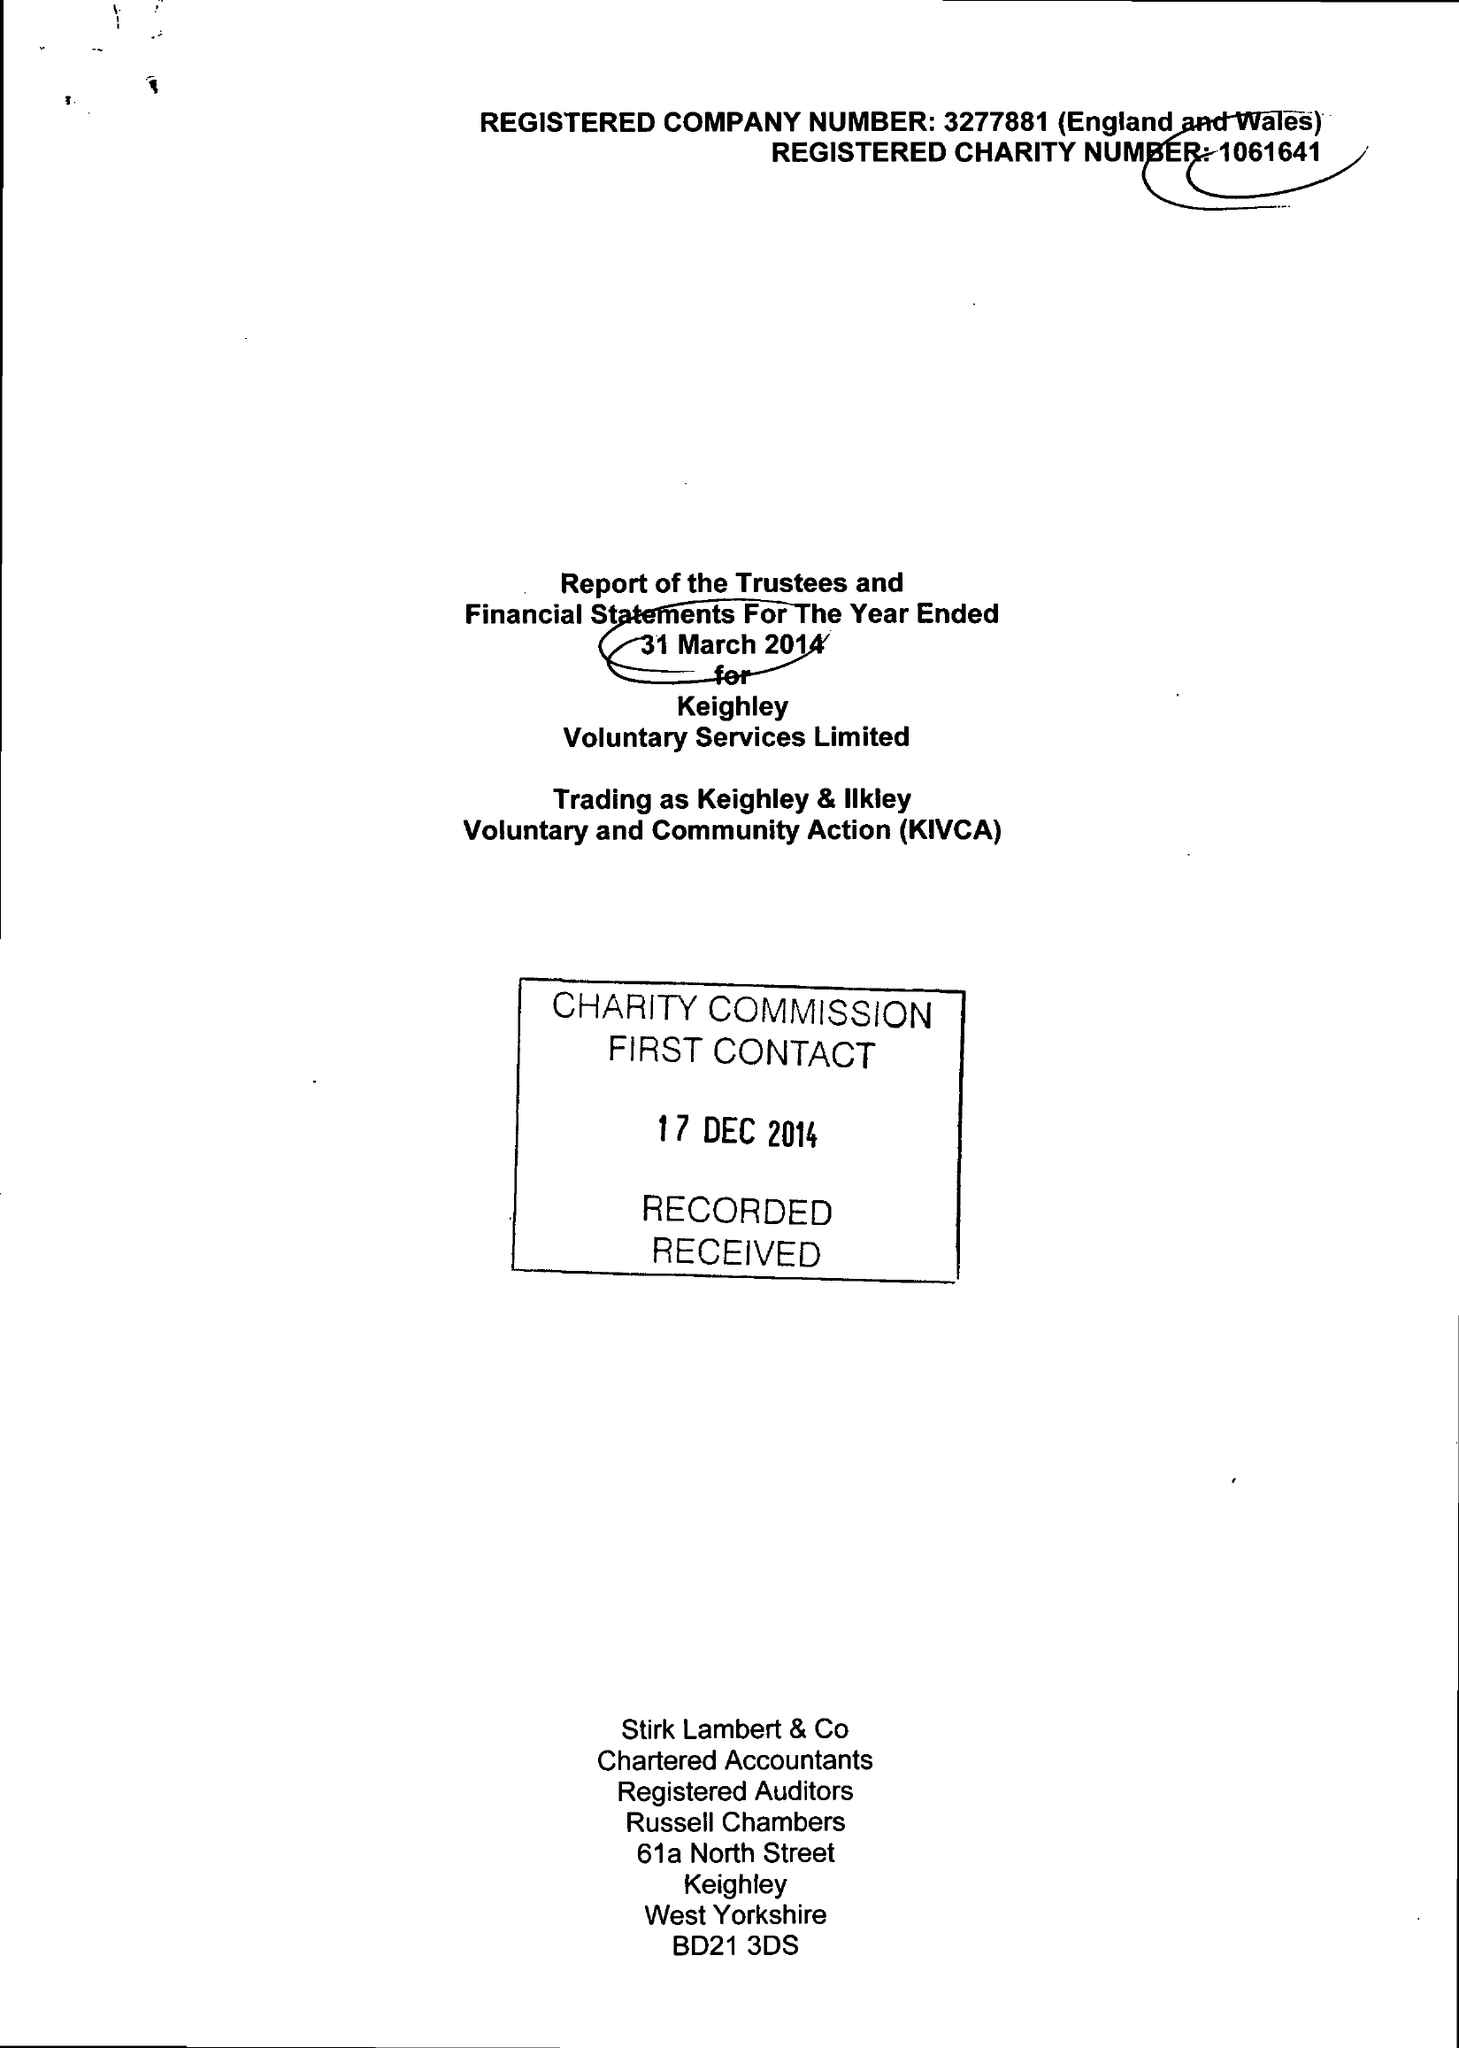What is the value for the address__post_town?
Answer the question using a single word or phrase. KEIGHLEY 